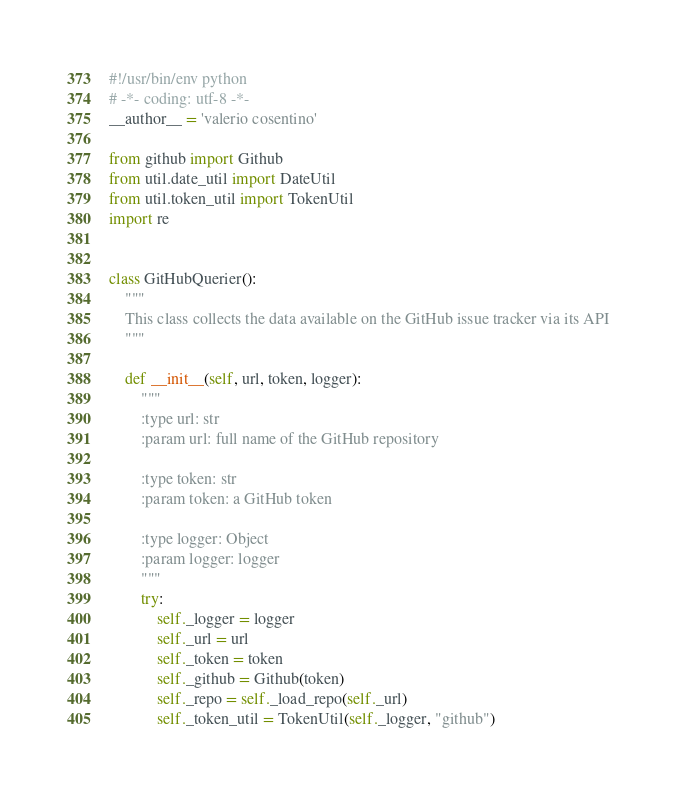<code> <loc_0><loc_0><loc_500><loc_500><_Python_>#!/usr/bin/env python
# -*- coding: utf-8 -*-
__author__ = 'valerio cosentino'

from github import Github
from util.date_util import DateUtil
from util.token_util import TokenUtil
import re


class GitHubQuerier():
    """
    This class collects the data available on the GitHub issue tracker via its API
    """

    def __init__(self, url, token, logger):
        """
        :type url: str
        :param url: full name of the GitHub repository

        :type token: str
        :param token: a GitHub token

        :type logger: Object
        :param logger: logger
        """
        try:
            self._logger = logger
            self._url = url
            self._token = token
            self._github = Github(token)
            self._repo = self._load_repo(self._url)
            self._token_util = TokenUtil(self._logger, "github")</code> 